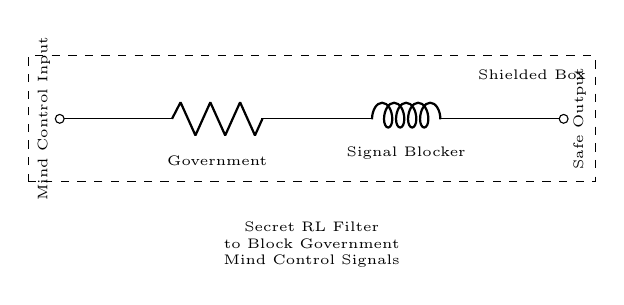What does R represent in this circuit? R represents a resistor in the circuit, labeled "Government," indicating its role in controlling the signal.
Answer: Resistor What is the function of the inductor in this circuit? The inductor, labeled "Signal Blocker," is used to impede changes in current, effectively filtering out unwanted signals.
Answer: Signal Blocker How many components are there in this circuit? There are two main components: one resistor and one inductor.
Answer: Two What type of circuit is depicted here? The circuit is a Resistor-Inductor (RL) filter circuit, which is specifically designed for filtering purposes.
Answer: RL filter circuit What is the output labeled as? The output is labeled "Safe Output," suggesting it is intended to provide a harmless signal after filtering.
Answer: Safe Output What is the input labeled as? The input is labeled "Mind Control Input," indicating the type of signal the circuit is designed to block.
Answer: Mind Control Input What is the purpose of the shielded box? The shielded box is designed to protect the circuit from external interference, ensuring the filter works effectively.
Answer: Protect interference 